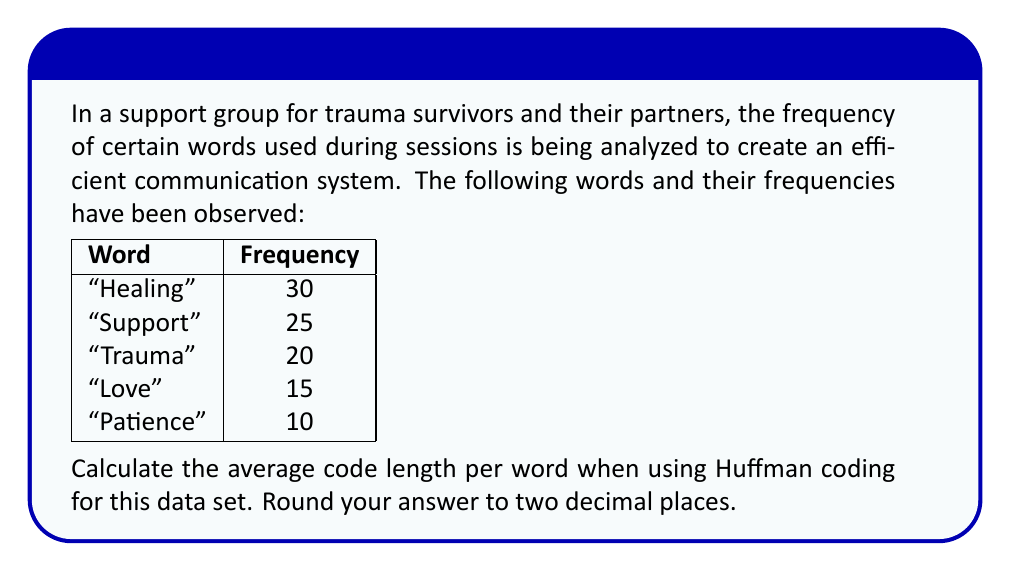Teach me how to tackle this problem. To solve this problem, we'll follow these steps:

1) First, let's create a Huffman tree:

[asy]
unitsize(1cm);

pair[] nodes = {(0,0), (2,0), (4,0), (6,0), (8,0), (3,1), (5,1), (7,1), (4,2), (6,2), (5,3)};
string[] labels = {"Patience", "Love", "Trauma", "Support", "Healing", "25", "45", "55", "70", "100", "100"};

for (int i = 0; i < nodes.length; ++i) {
  dot(nodes[i]);
  label(labels[i], nodes[i], S);
}

draw(nodes[0]--nodes[5]);
draw(nodes[1]--nodes[5]);
draw(nodes[2]--nodes[6]);
draw(nodes[5]--nodes[6]);
draw(nodes[3]--nodes[7]);
draw(nodes[4]--nodes[7]);
draw(nodes[6]--nodes[8]);
draw(nodes[7]--nodes[8]);
draw(nodes[8]--nodes[9]);
draw(nodes[9]--nodes[10]);
[/asy]

2) Now, let's determine the code for each word:

   Healing: 11
   Support: 10
   Trauma: 011
   Love: 0100
   Patience: 0101

3) Calculate the length of each code:

   Healing: 2 bits
   Support: 2 bits
   Trauma: 3 bits
   Love: 4 bits
   Patience: 4 bits

4) Multiply each code length by its frequency:

   Healing: 2 * 30 = 60
   Support: 2 * 25 = 50
   Trauma: 3 * 20 = 60
   Love: 4 * 15 = 60
   Patience: 4 * 10 = 40

5) Sum up these products:

   60 + 50 + 60 + 60 + 40 = 270

6) Calculate the total frequency:

   30 + 25 + 20 + 15 + 10 = 100

7) Divide the sum of products by the total frequency:

   $\frac{270}{100} = 2.70$

Therefore, the average code length per word is 2.70 bits.
Answer: 2.70 bits 